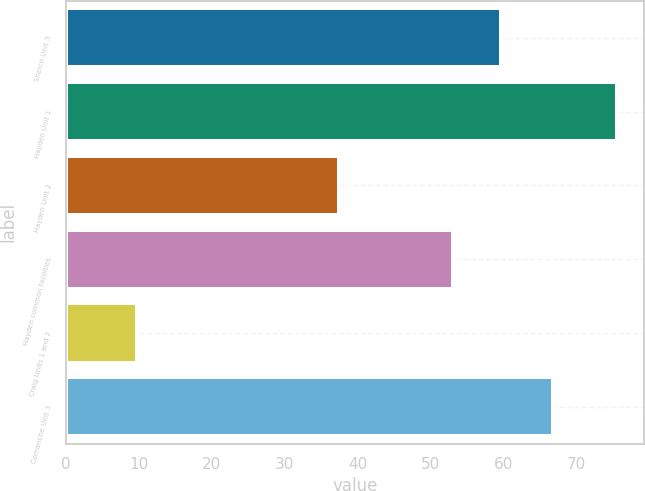Convert chart to OTSL. <chart><loc_0><loc_0><loc_500><loc_500><bar_chart><fcel>Sherco Unit 3<fcel>Hayden Unit 1<fcel>Hayden Unit 2<fcel>Hayden common facilities<fcel>Craig Units 1 and 2<fcel>Comanche Unit 3<nl><fcel>59.68<fcel>75.5<fcel>37.4<fcel>53.1<fcel>9.7<fcel>66.7<nl></chart> 